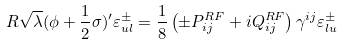Convert formula to latex. <formula><loc_0><loc_0><loc_500><loc_500>R \sqrt { \lambda } ( \phi + { \frac { 1 } { 2 } } \sigma ) ^ { \prime } \varepsilon _ { u l } ^ { \pm } = { \frac { 1 } { 8 } } \left ( \pm { P } _ { i j } ^ { R F } + i { Q } _ { i j } ^ { R F } \right ) \gamma ^ { i j } \varepsilon _ { l u } ^ { \pm }</formula> 